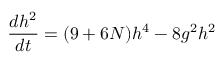<formula> <loc_0><loc_0><loc_500><loc_500>\frac { d h ^ { 2 } } { d t } = ( 9 + 6 N ) h ^ { 4 } - 8 g ^ { 2 } h ^ { 2 }</formula> 